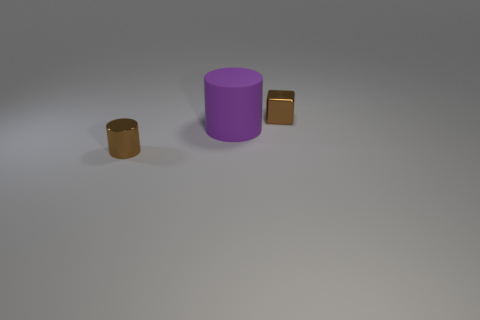Add 3 red objects. How many objects exist? 6 Subtract all brown cylinders. How many cylinders are left? 1 Subtract 1 blocks. How many blocks are left? 0 Subtract all purple cubes. How many purple cylinders are left? 1 Subtract all cylinders. How many objects are left? 1 Subtract all red cylinders. Subtract all red spheres. How many cylinders are left? 2 Subtract all big red objects. Subtract all tiny brown metallic objects. How many objects are left? 1 Add 3 big rubber cylinders. How many big rubber cylinders are left? 4 Add 3 large purple rubber spheres. How many large purple rubber spheres exist? 3 Subtract 0 yellow blocks. How many objects are left? 3 